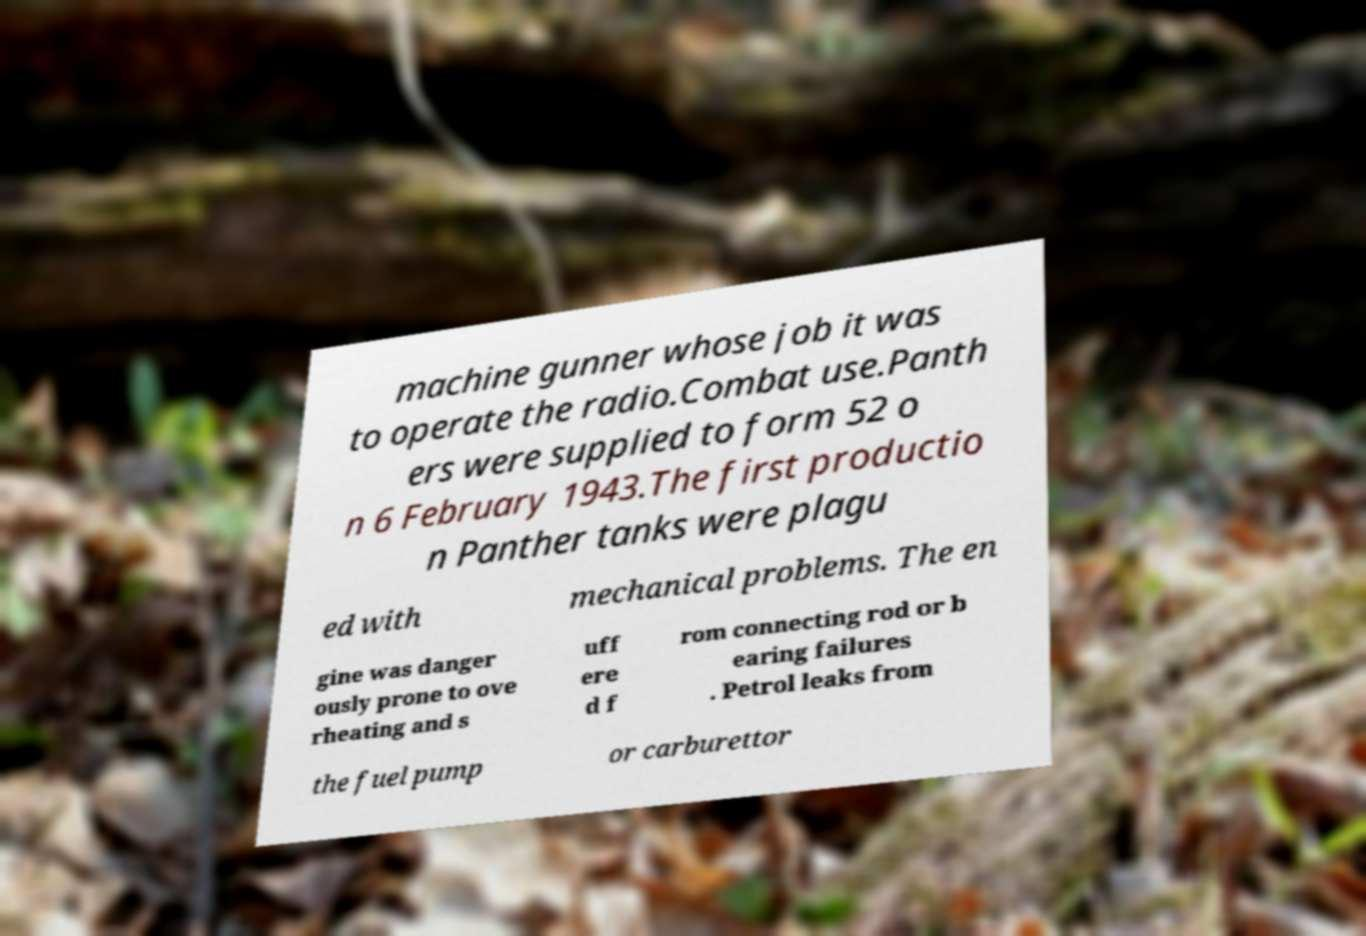There's text embedded in this image that I need extracted. Can you transcribe it verbatim? machine gunner whose job it was to operate the radio.Combat use.Panth ers were supplied to form 52 o n 6 February 1943.The first productio n Panther tanks were plagu ed with mechanical problems. The en gine was danger ously prone to ove rheating and s uff ere d f rom connecting rod or b earing failures . Petrol leaks from the fuel pump or carburettor 